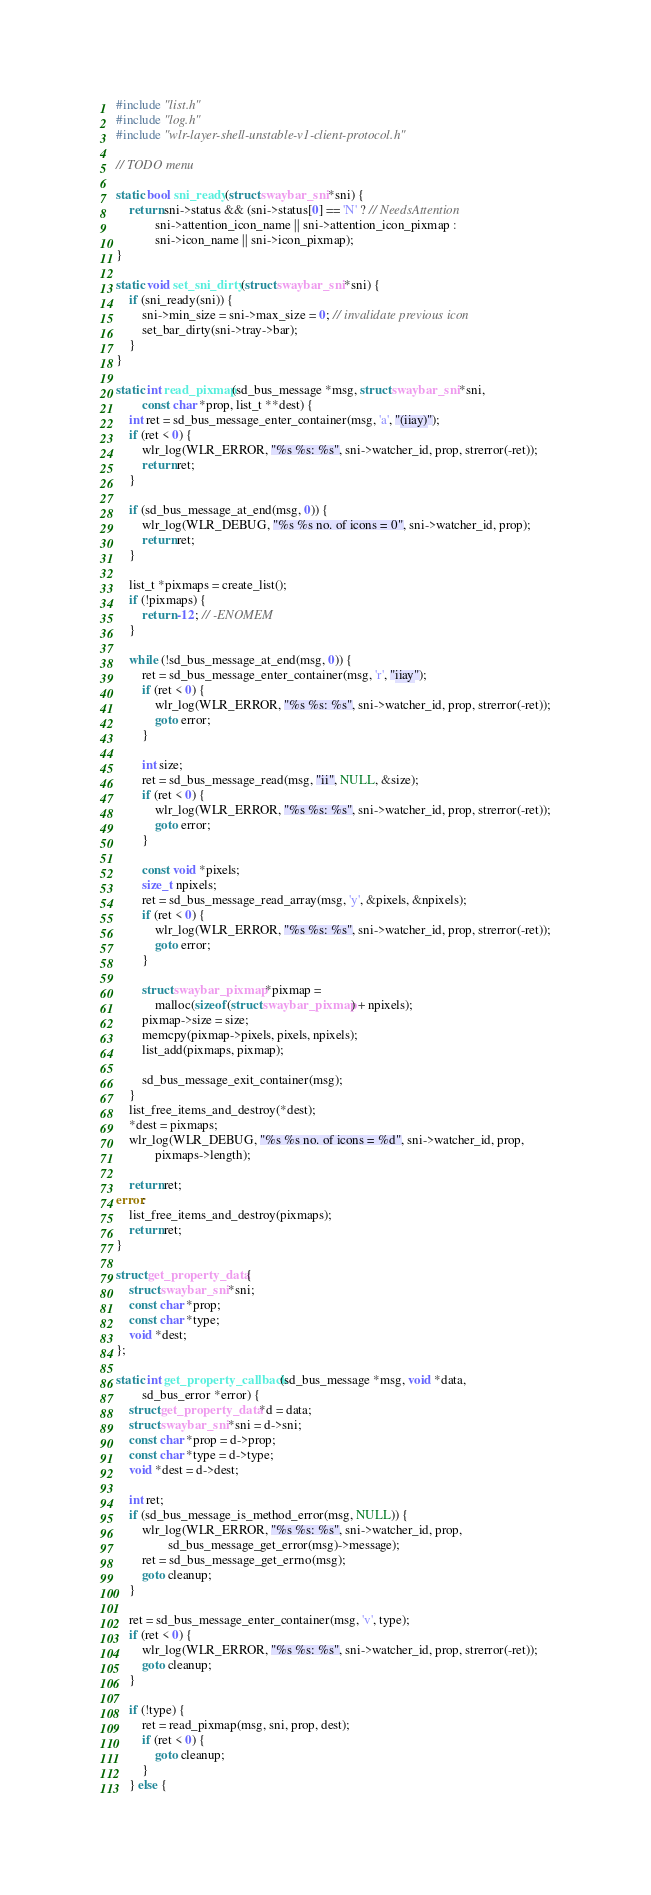Convert code to text. <code><loc_0><loc_0><loc_500><loc_500><_C_>#include "list.h"
#include "log.h"
#include "wlr-layer-shell-unstable-v1-client-protocol.h"

// TODO menu

static bool sni_ready(struct swaybar_sni *sni) {
	return sni->status && (sni->status[0] == 'N' ? // NeedsAttention
			sni->attention_icon_name || sni->attention_icon_pixmap :
			sni->icon_name || sni->icon_pixmap);
}

static void set_sni_dirty(struct swaybar_sni *sni) {
	if (sni_ready(sni)) {
		sni->min_size = sni->max_size = 0; // invalidate previous icon
		set_bar_dirty(sni->tray->bar);
	}
}

static int read_pixmap(sd_bus_message *msg, struct swaybar_sni *sni,
		const char *prop, list_t **dest) {
	int ret = sd_bus_message_enter_container(msg, 'a', "(iiay)");
	if (ret < 0) {
		wlr_log(WLR_ERROR, "%s %s: %s", sni->watcher_id, prop, strerror(-ret));
		return ret;
	}

	if (sd_bus_message_at_end(msg, 0)) {
		wlr_log(WLR_DEBUG, "%s %s no. of icons = 0", sni->watcher_id, prop);
		return ret;
	}

	list_t *pixmaps = create_list();
	if (!pixmaps) {
		return -12; // -ENOMEM
	}

	while (!sd_bus_message_at_end(msg, 0)) {
		ret = sd_bus_message_enter_container(msg, 'r', "iiay");
		if (ret < 0) {
			wlr_log(WLR_ERROR, "%s %s: %s", sni->watcher_id, prop, strerror(-ret));
			goto error;
		}

		int size;
		ret = sd_bus_message_read(msg, "ii", NULL, &size);
		if (ret < 0) {
			wlr_log(WLR_ERROR, "%s %s: %s", sni->watcher_id, prop, strerror(-ret));
			goto error;
		}

		const void *pixels;
		size_t npixels;
		ret = sd_bus_message_read_array(msg, 'y', &pixels, &npixels);
		if (ret < 0) {
			wlr_log(WLR_ERROR, "%s %s: %s", sni->watcher_id, prop, strerror(-ret));
			goto error;
		}

		struct swaybar_pixmap *pixmap =
			malloc(sizeof(struct swaybar_pixmap) + npixels);
		pixmap->size = size;
		memcpy(pixmap->pixels, pixels, npixels);
		list_add(pixmaps, pixmap);

		sd_bus_message_exit_container(msg);
	}
	list_free_items_and_destroy(*dest);
	*dest = pixmaps;
	wlr_log(WLR_DEBUG, "%s %s no. of icons = %d", sni->watcher_id, prop,
			pixmaps->length);

	return ret;
error:
	list_free_items_and_destroy(pixmaps);
	return ret;
}

struct get_property_data {
	struct swaybar_sni *sni;
	const char *prop;
	const char *type;
	void *dest;
};

static int get_property_callback(sd_bus_message *msg, void *data,
		sd_bus_error *error) {
	struct get_property_data *d = data;
	struct swaybar_sni *sni = d->sni;
	const char *prop = d->prop;
	const char *type = d->type;
	void *dest = d->dest;

	int ret;
	if (sd_bus_message_is_method_error(msg, NULL)) {
		wlr_log(WLR_ERROR, "%s %s: %s", sni->watcher_id, prop,
				sd_bus_message_get_error(msg)->message);
		ret = sd_bus_message_get_errno(msg);
		goto cleanup;
	}

	ret = sd_bus_message_enter_container(msg, 'v', type);
	if (ret < 0) {
		wlr_log(WLR_ERROR, "%s %s: %s", sni->watcher_id, prop, strerror(-ret));
		goto cleanup;
	}

	if (!type) {
		ret = read_pixmap(msg, sni, prop, dest);
		if (ret < 0) {
			goto cleanup;
		}
	} else {</code> 